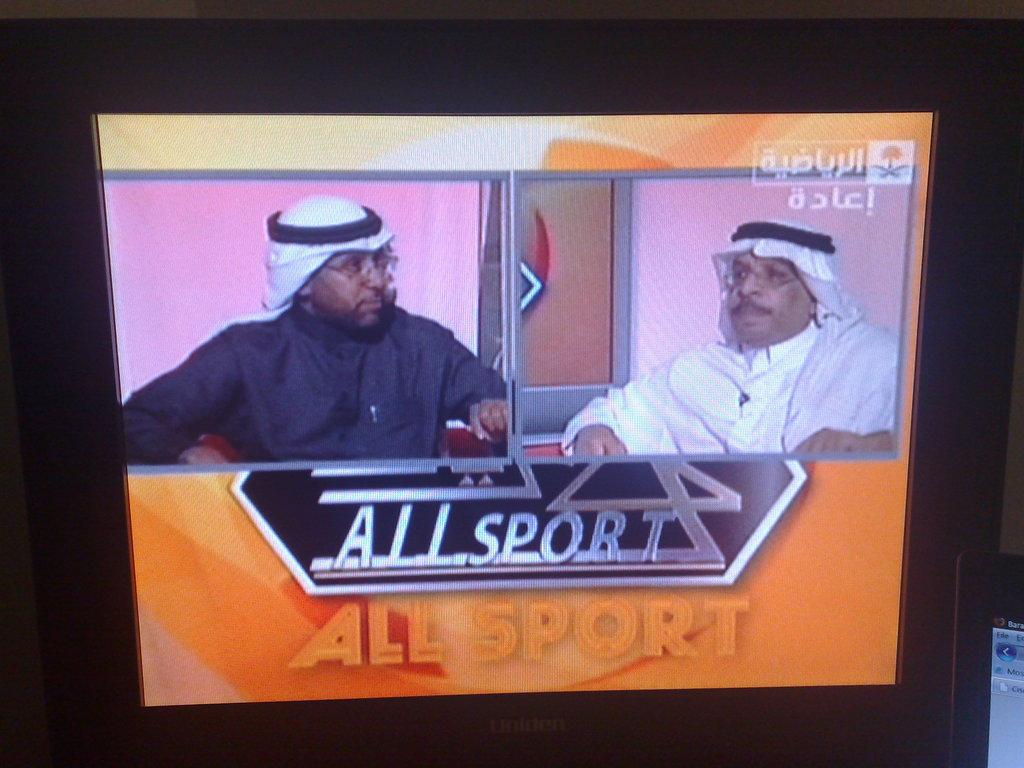Is allsport mentioned here?
Your answer should be compact. Yes. 